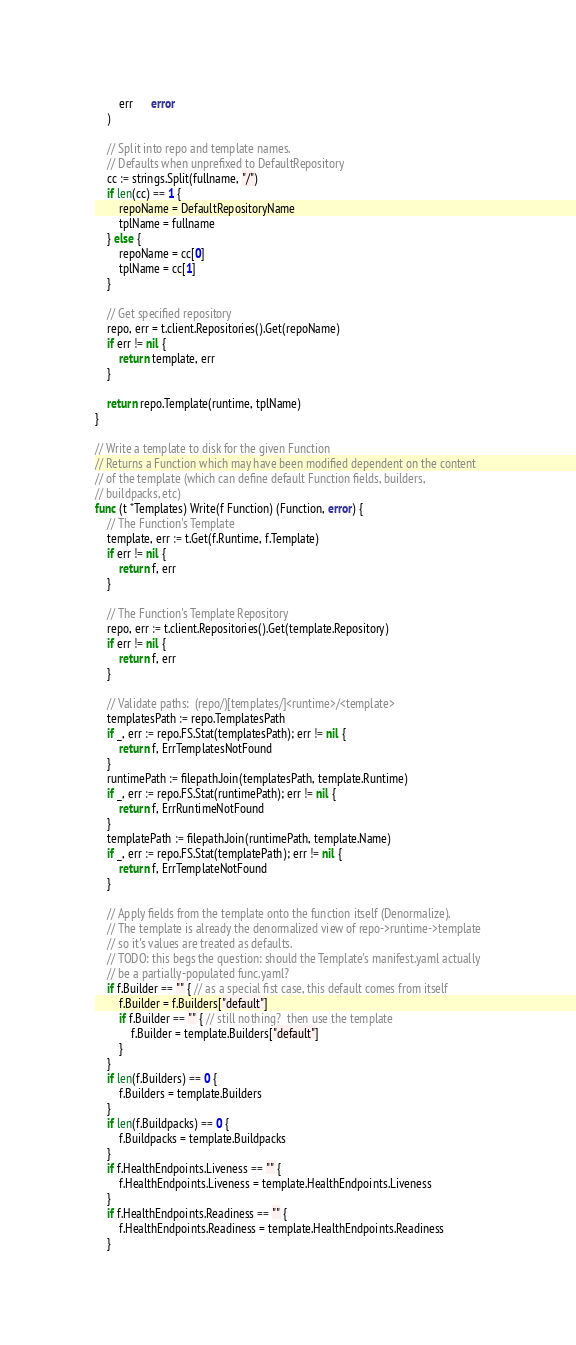<code> <loc_0><loc_0><loc_500><loc_500><_Go_>		err      error
	)

	// Split into repo and template names.
	// Defaults when unprefixed to DefaultRepository
	cc := strings.Split(fullname, "/")
	if len(cc) == 1 {
		repoName = DefaultRepositoryName
		tplName = fullname
	} else {
		repoName = cc[0]
		tplName = cc[1]
	}

	// Get specified repository
	repo, err = t.client.Repositories().Get(repoName)
	if err != nil {
		return template, err
	}

	return repo.Template(runtime, tplName)
}

// Write a template to disk for the given Function
// Returns a Function which may have been modified dependent on the content
// of the template (which can define default Function fields, builders,
// buildpacks, etc)
func (t *Templates) Write(f Function) (Function, error) {
	// The Function's Template
	template, err := t.Get(f.Runtime, f.Template)
	if err != nil {
		return f, err
	}

	// The Function's Template Repository
	repo, err := t.client.Repositories().Get(template.Repository)
	if err != nil {
		return f, err
	}

	// Validate paths:  (repo/)[templates/]<runtime>/<template>
	templatesPath := repo.TemplatesPath
	if _, err := repo.FS.Stat(templatesPath); err != nil {
		return f, ErrTemplatesNotFound
	}
	runtimePath := filepath.Join(templatesPath, template.Runtime)
	if _, err := repo.FS.Stat(runtimePath); err != nil {
		return f, ErrRuntimeNotFound
	}
	templatePath := filepath.Join(runtimePath, template.Name)
	if _, err := repo.FS.Stat(templatePath); err != nil {
		return f, ErrTemplateNotFound
	}

	// Apply fields from the template onto the function itself (Denormalize).
	// The template is already the denormalized view of repo->runtime->template
	// so it's values are treated as defaults.
	// TODO: this begs the question: should the Template's manifest.yaml actually
	// be a partially-populated func.yaml?
	if f.Builder == "" { // as a special fist case, this default comes from itself
		f.Builder = f.Builders["default"]
		if f.Builder == "" { // still nothing?  then use the template
			f.Builder = template.Builders["default"]
		}
	}
	if len(f.Builders) == 0 {
		f.Builders = template.Builders
	}
	if len(f.Buildpacks) == 0 {
		f.Buildpacks = template.Buildpacks
	}
	if f.HealthEndpoints.Liveness == "" {
		f.HealthEndpoints.Liveness = template.HealthEndpoints.Liveness
	}
	if f.HealthEndpoints.Readiness == "" {
		f.HealthEndpoints.Readiness = template.HealthEndpoints.Readiness
	}
</code> 